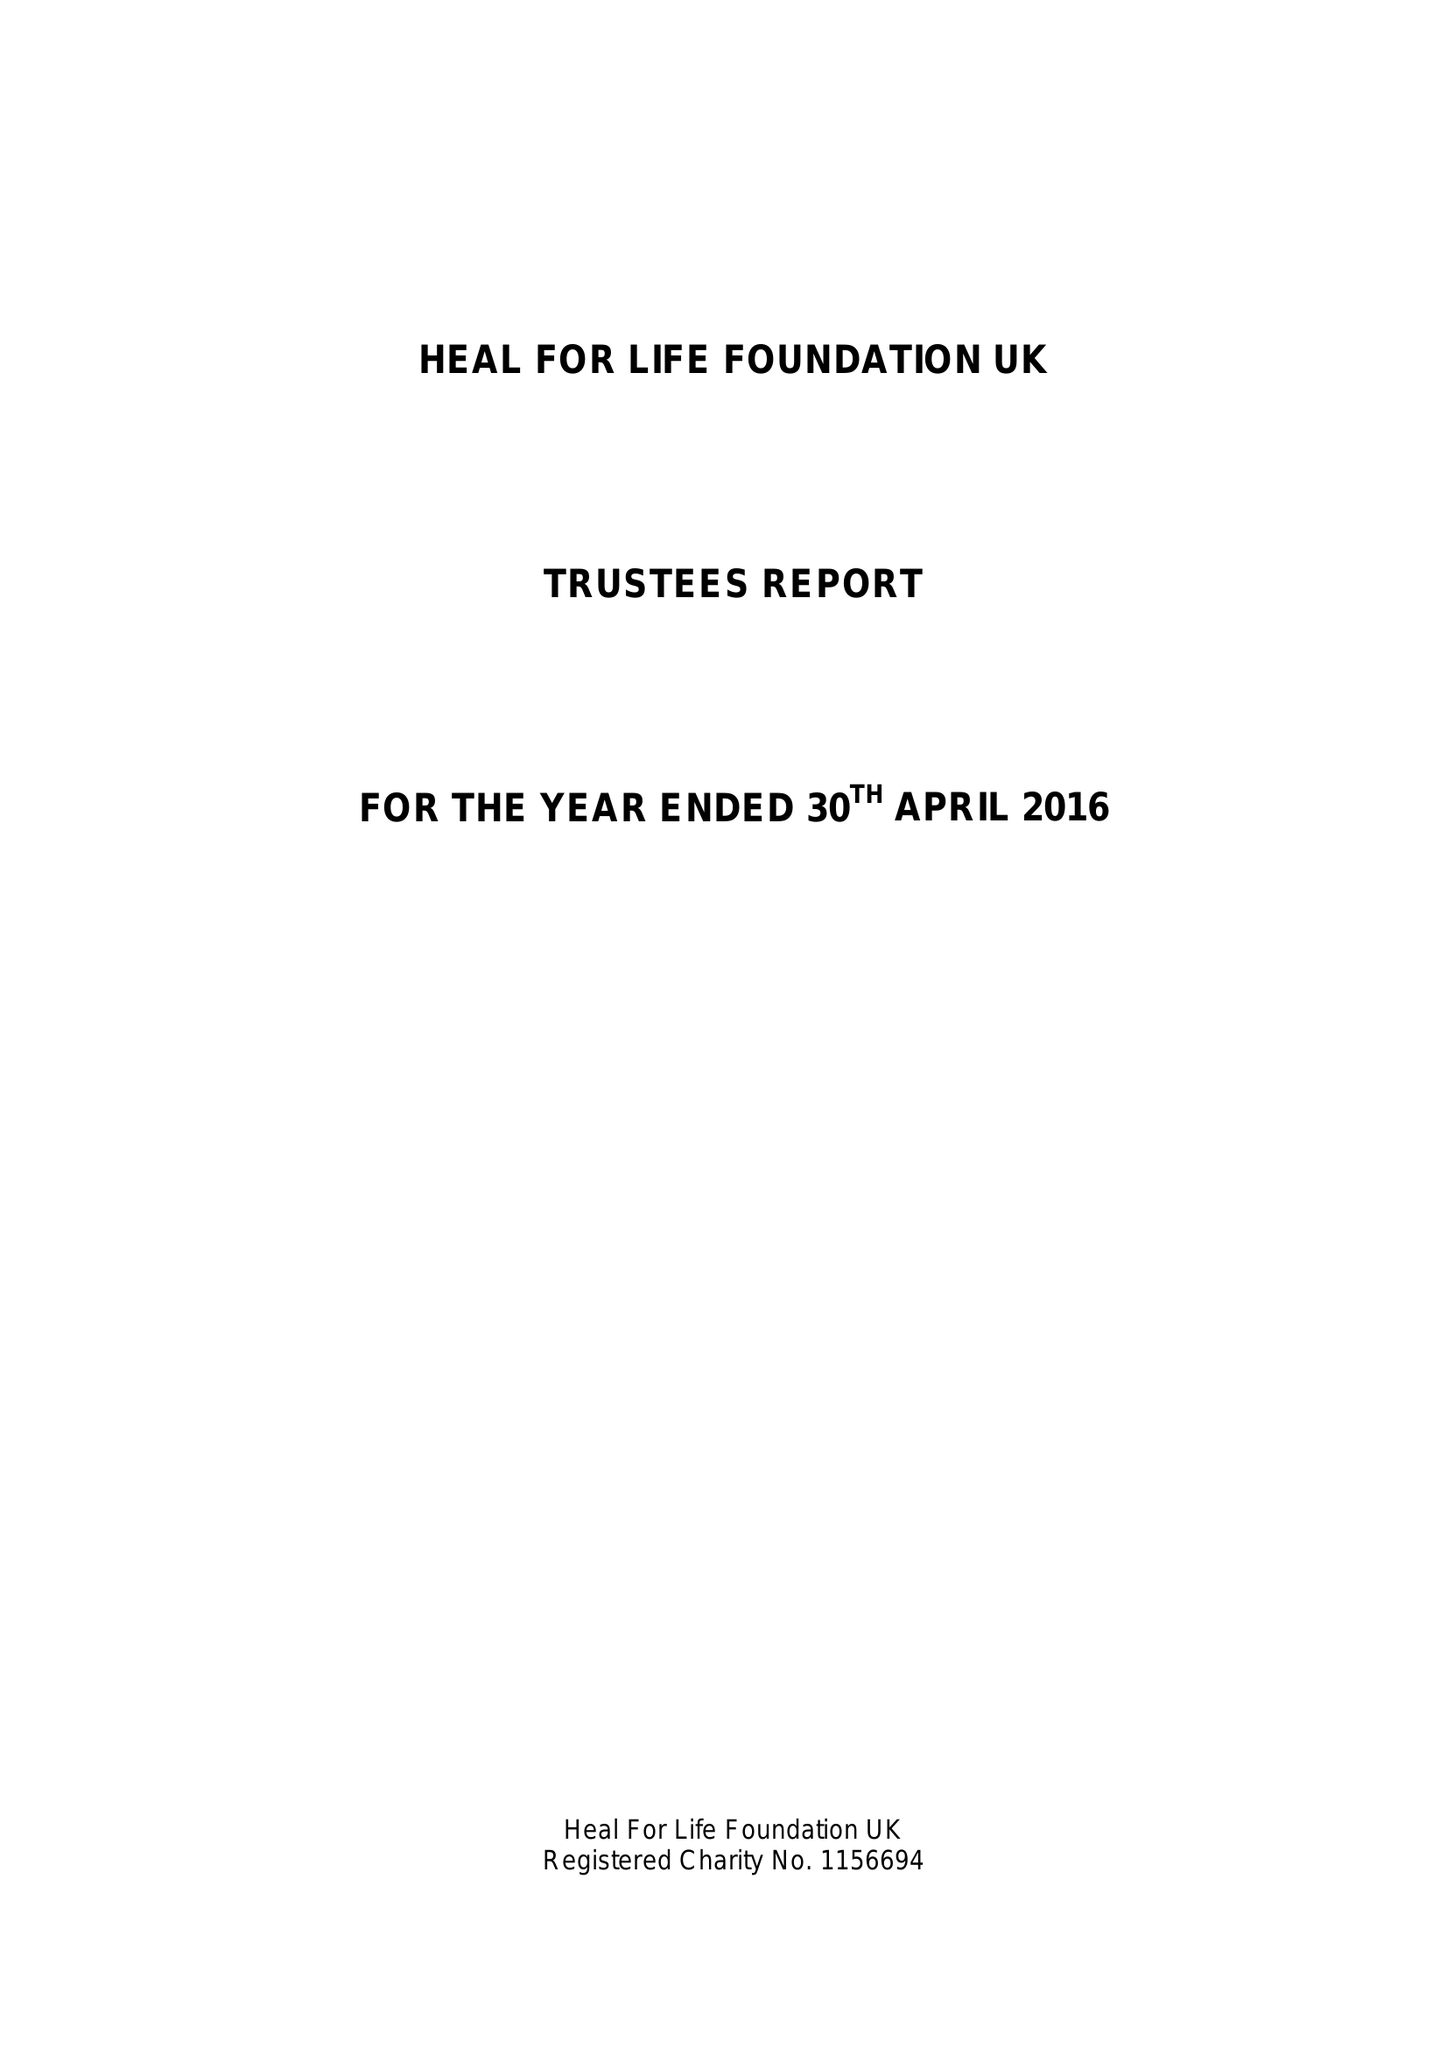What is the value for the report_date?
Answer the question using a single word or phrase. 2016-04-30 